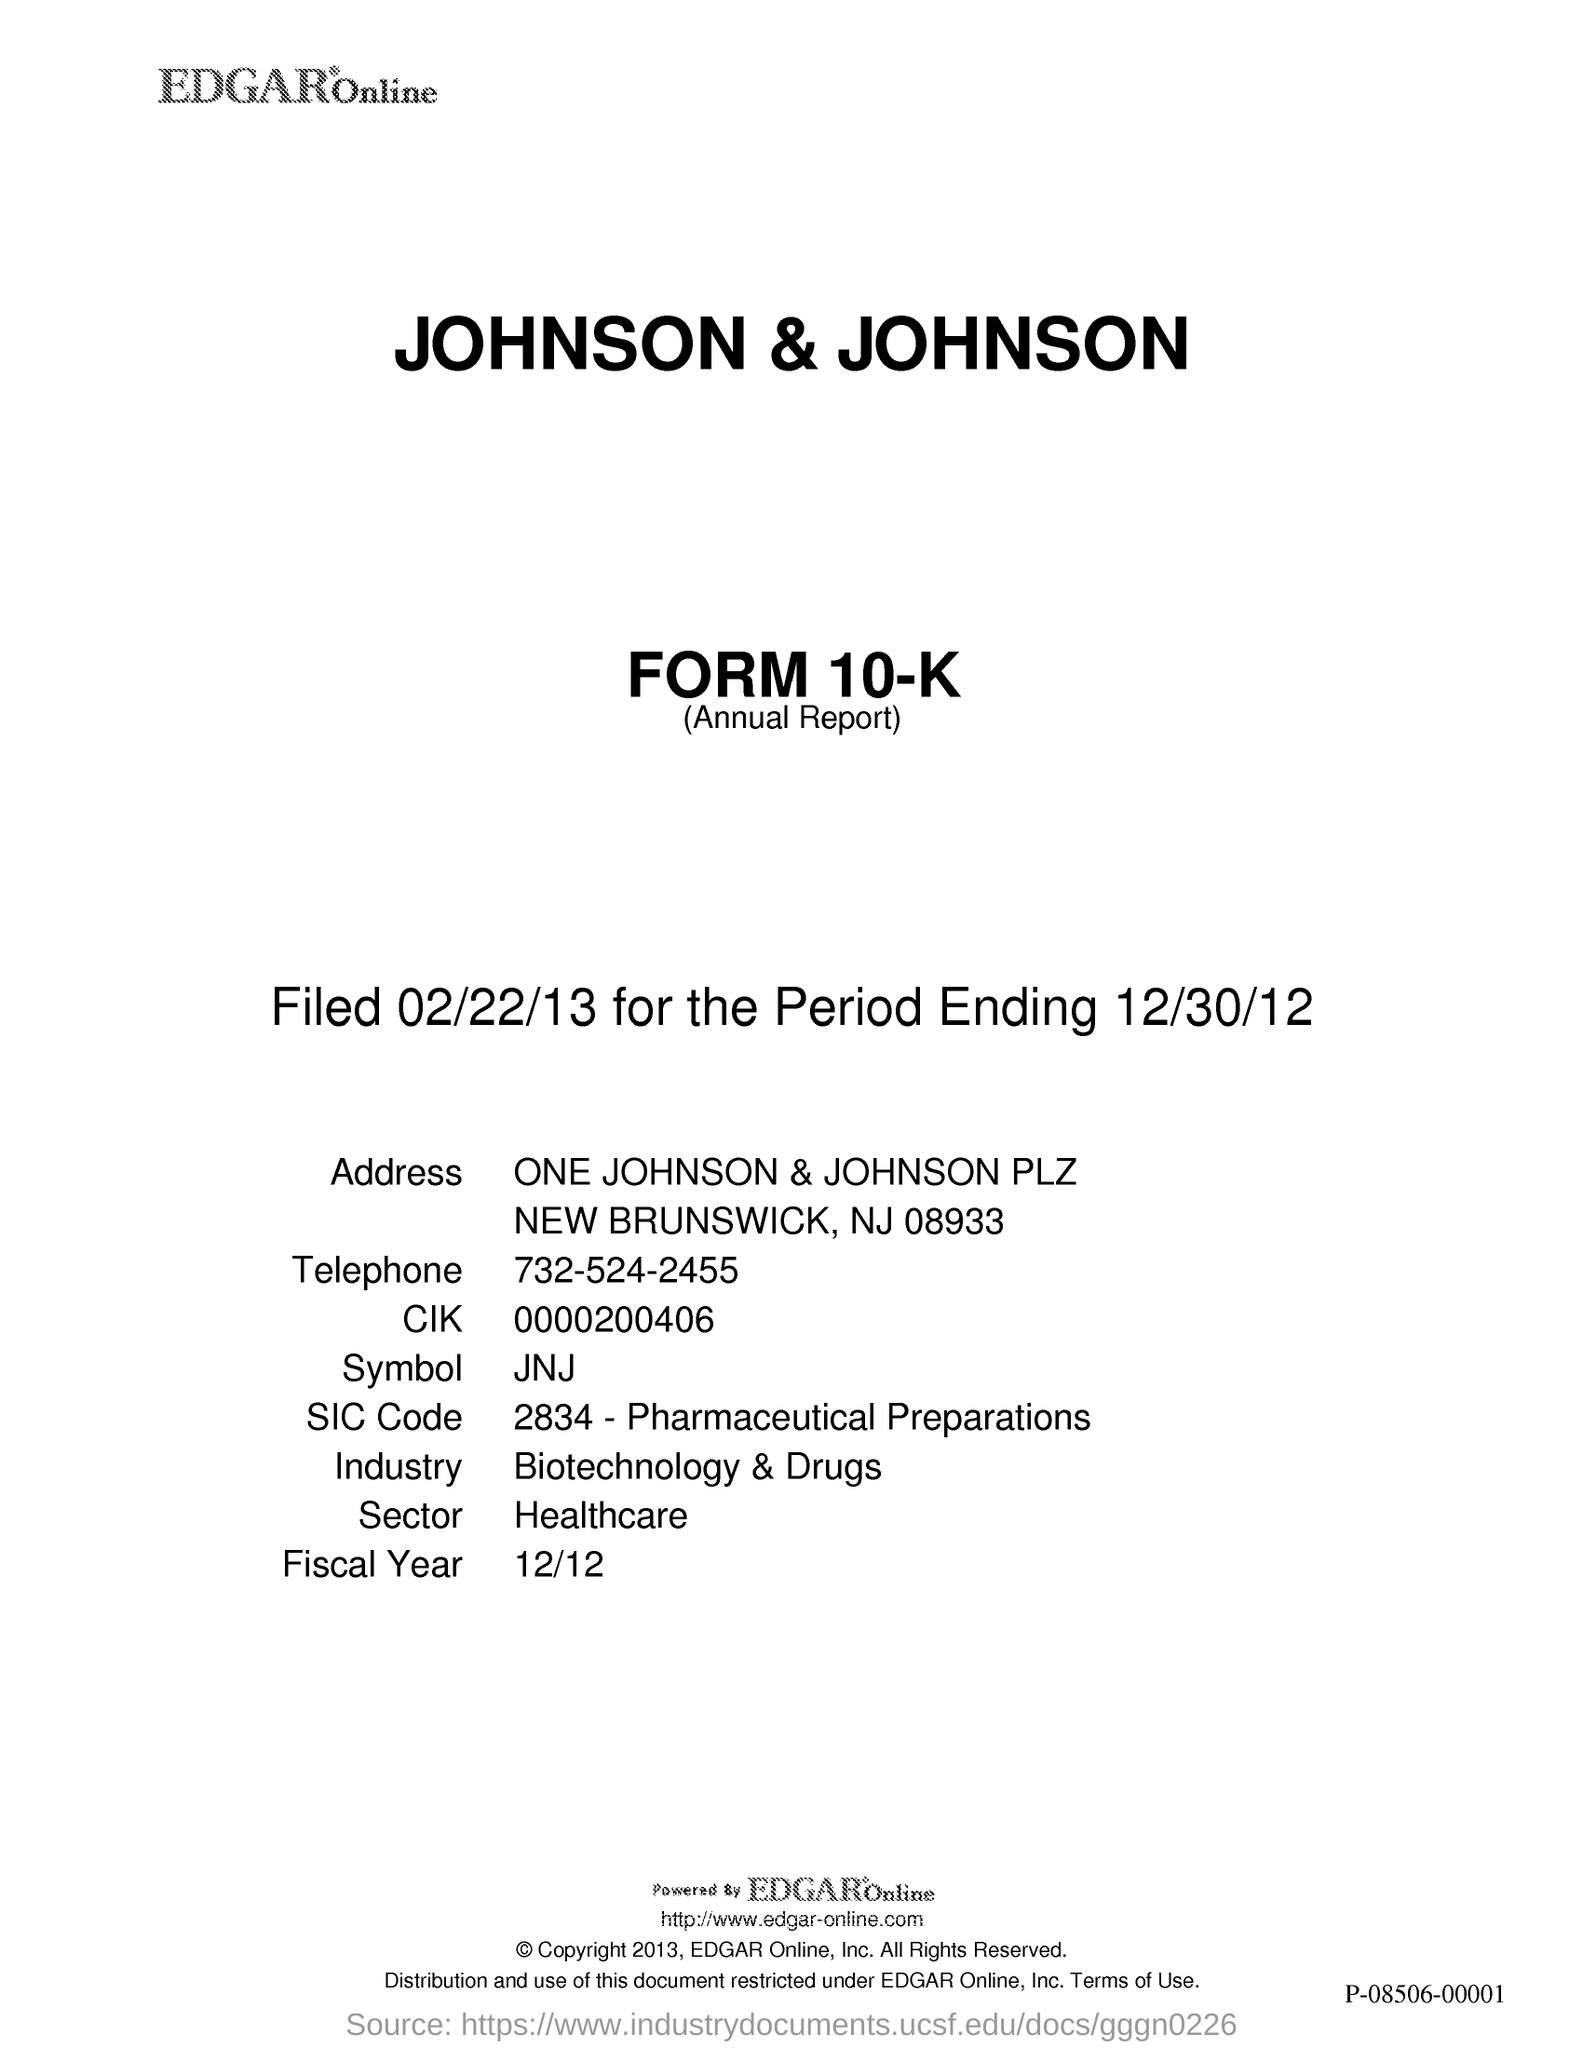What is the Telephone No given in this document?
Your answer should be compact. 732-524-2455. What is the industry type of the Johnson & Johnson company?
Provide a short and direct response. Biotechnology &drugs. In which sector, the Johnson & Johnson company belongs to?
Offer a very short reply. HEALTHCARE. Which fiscal year is mentioned in the document?
Offer a very short reply. 12/12. 